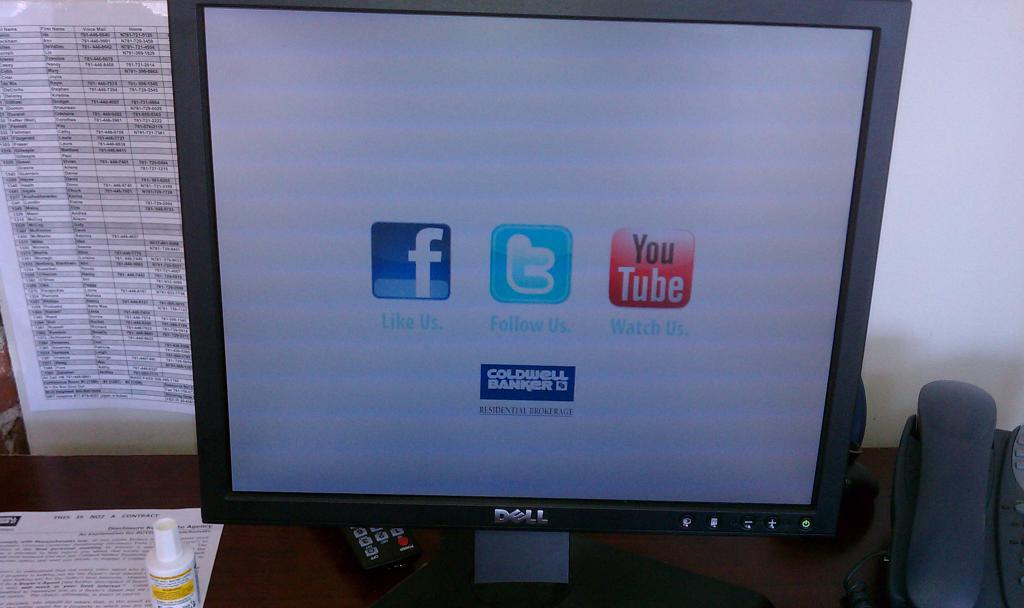Provide a one-sentence caption for the provided image. The screen of a dell monitor with logos for facebook and twitter. 